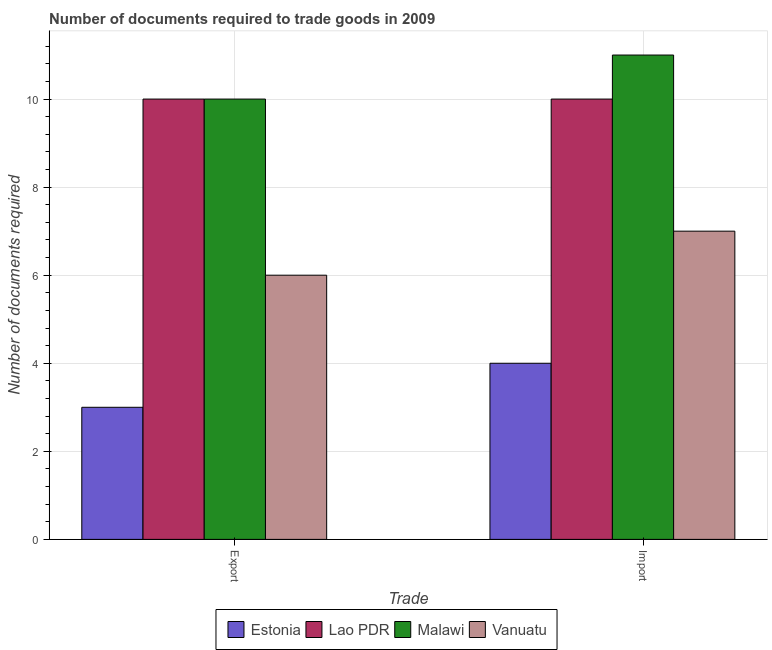Are the number of bars per tick equal to the number of legend labels?
Provide a succinct answer. Yes. Are the number of bars on each tick of the X-axis equal?
Your answer should be very brief. Yes. What is the label of the 2nd group of bars from the left?
Offer a terse response. Import. What is the number of documents required to export goods in Lao PDR?
Ensure brevity in your answer.  10. Across all countries, what is the maximum number of documents required to export goods?
Your answer should be compact. 10. Across all countries, what is the minimum number of documents required to import goods?
Your answer should be compact. 4. In which country was the number of documents required to export goods maximum?
Provide a short and direct response. Lao PDR. In which country was the number of documents required to export goods minimum?
Ensure brevity in your answer.  Estonia. What is the total number of documents required to import goods in the graph?
Offer a very short reply. 32. What is the difference between the number of documents required to export goods in Estonia and that in Malawi?
Provide a succinct answer. -7. What is the difference between the number of documents required to import goods in Estonia and the number of documents required to export goods in Malawi?
Ensure brevity in your answer.  -6. What is the average number of documents required to import goods per country?
Offer a terse response. 8. What is the difference between the number of documents required to import goods and number of documents required to export goods in Estonia?
Offer a terse response. 1. What does the 2nd bar from the left in Export represents?
Provide a succinct answer. Lao PDR. What does the 2nd bar from the right in Import represents?
Your answer should be very brief. Malawi. Are all the bars in the graph horizontal?
Keep it short and to the point. No. What is the difference between two consecutive major ticks on the Y-axis?
Offer a terse response. 2. Are the values on the major ticks of Y-axis written in scientific E-notation?
Keep it short and to the point. No. Does the graph contain any zero values?
Provide a short and direct response. No. Does the graph contain grids?
Offer a very short reply. Yes. How many legend labels are there?
Make the answer very short. 4. How are the legend labels stacked?
Ensure brevity in your answer.  Horizontal. What is the title of the graph?
Keep it short and to the point. Number of documents required to trade goods in 2009. What is the label or title of the X-axis?
Ensure brevity in your answer.  Trade. What is the label or title of the Y-axis?
Provide a short and direct response. Number of documents required. What is the Number of documents required in Lao PDR in Export?
Keep it short and to the point. 10. What is the Number of documents required of Malawi in Export?
Provide a short and direct response. 10. What is the Number of documents required of Vanuatu in Export?
Keep it short and to the point. 6. What is the Number of documents required in Lao PDR in Import?
Provide a short and direct response. 10. What is the Number of documents required in Malawi in Import?
Offer a very short reply. 11. What is the Number of documents required in Vanuatu in Import?
Your answer should be compact. 7. Across all Trade, what is the maximum Number of documents required of Lao PDR?
Your answer should be very brief. 10. Across all Trade, what is the maximum Number of documents required in Malawi?
Provide a succinct answer. 11. Across all Trade, what is the minimum Number of documents required of Lao PDR?
Offer a terse response. 10. Across all Trade, what is the minimum Number of documents required of Malawi?
Offer a terse response. 10. Across all Trade, what is the minimum Number of documents required of Vanuatu?
Offer a very short reply. 6. What is the total Number of documents required in Estonia in the graph?
Your response must be concise. 7. What is the total Number of documents required in Lao PDR in the graph?
Your answer should be very brief. 20. What is the total Number of documents required of Malawi in the graph?
Keep it short and to the point. 21. What is the difference between the Number of documents required in Vanuatu in Export and that in Import?
Provide a succinct answer. -1. What is the difference between the Number of documents required of Estonia in Export and the Number of documents required of Lao PDR in Import?
Your response must be concise. -7. What is the difference between the Number of documents required of Lao PDR in Export and the Number of documents required of Vanuatu in Import?
Your answer should be compact. 3. What is the average Number of documents required in Estonia per Trade?
Offer a very short reply. 3.5. What is the average Number of documents required in Vanuatu per Trade?
Make the answer very short. 6.5. What is the difference between the Number of documents required in Estonia and Number of documents required in Vanuatu in Export?
Ensure brevity in your answer.  -3. What is the difference between the Number of documents required in Estonia and Number of documents required in Lao PDR in Import?
Keep it short and to the point. -6. What is the difference between the Number of documents required in Estonia and Number of documents required in Malawi in Import?
Provide a short and direct response. -7. What is the difference between the Number of documents required in Estonia and Number of documents required in Vanuatu in Import?
Your answer should be compact. -3. What is the difference between the Number of documents required of Lao PDR and Number of documents required of Malawi in Import?
Your answer should be very brief. -1. What is the difference between the Number of documents required of Lao PDR and Number of documents required of Vanuatu in Import?
Provide a succinct answer. 3. What is the difference between the Number of documents required of Malawi and Number of documents required of Vanuatu in Import?
Make the answer very short. 4. What is the ratio of the Number of documents required of Estonia in Export to that in Import?
Give a very brief answer. 0.75. What is the ratio of the Number of documents required in Lao PDR in Export to that in Import?
Offer a very short reply. 1. What is the ratio of the Number of documents required in Vanuatu in Export to that in Import?
Keep it short and to the point. 0.86. What is the difference between the highest and the second highest Number of documents required in Estonia?
Provide a short and direct response. 1. What is the difference between the highest and the second highest Number of documents required of Lao PDR?
Keep it short and to the point. 0. What is the difference between the highest and the second highest Number of documents required of Malawi?
Provide a succinct answer. 1. What is the difference between the highest and the second highest Number of documents required in Vanuatu?
Your response must be concise. 1. What is the difference between the highest and the lowest Number of documents required in Lao PDR?
Your answer should be very brief. 0. 